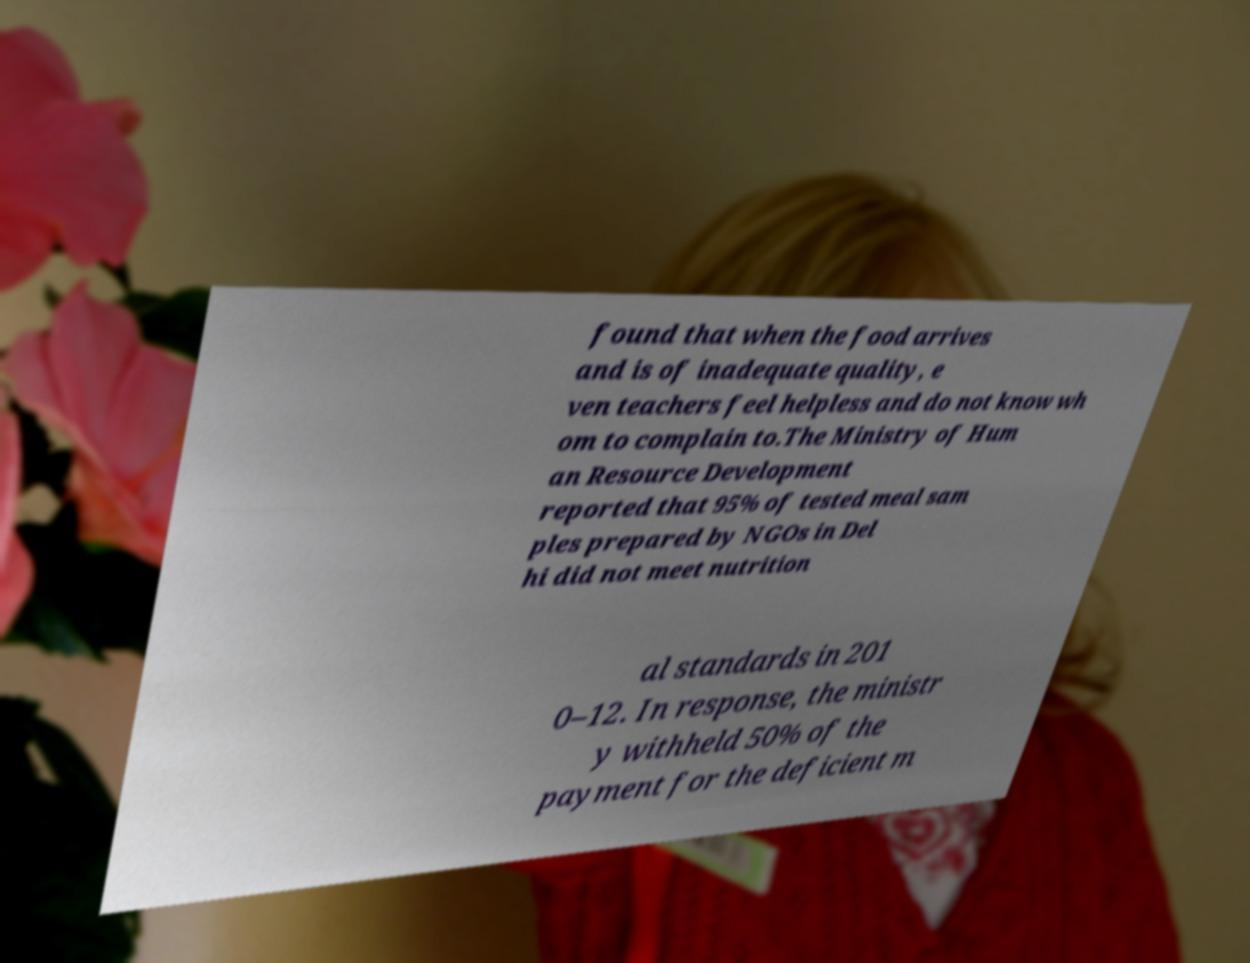Can you read and provide the text displayed in the image?This photo seems to have some interesting text. Can you extract and type it out for me? found that when the food arrives and is of inadequate quality, e ven teachers feel helpless and do not know wh om to complain to.The Ministry of Hum an Resource Development reported that 95% of tested meal sam ples prepared by NGOs in Del hi did not meet nutrition al standards in 201 0–12. In response, the ministr y withheld 50% of the payment for the deficient m 